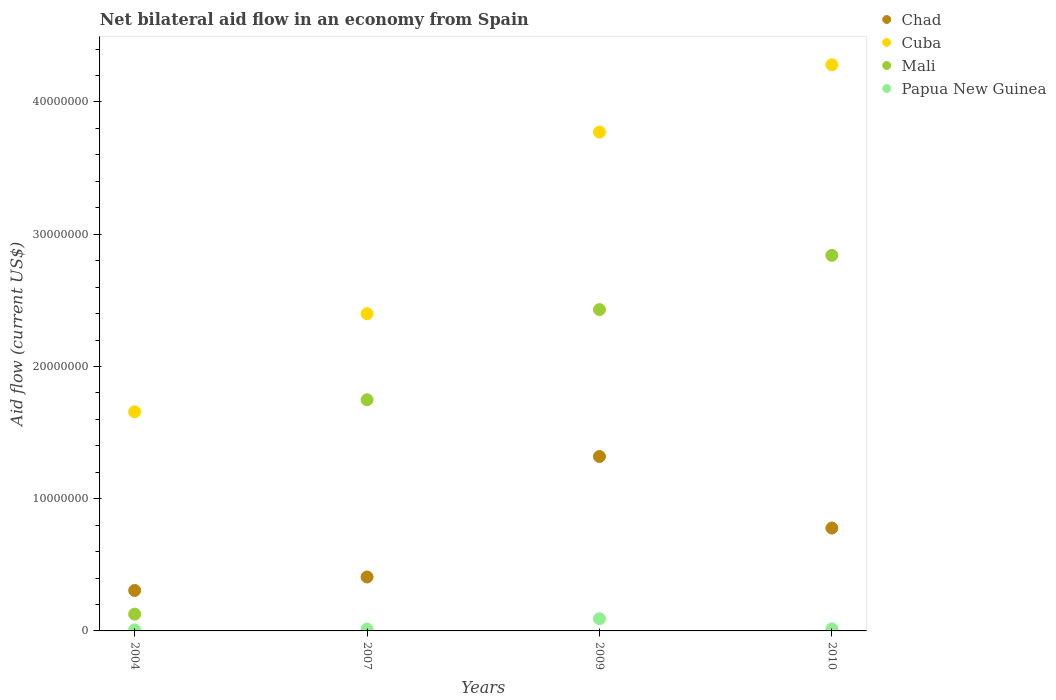Is the number of dotlines equal to the number of legend labels?
Your answer should be very brief. Yes. Across all years, what is the maximum net bilateral aid flow in Mali?
Ensure brevity in your answer.  2.84e+07. Across all years, what is the minimum net bilateral aid flow in Papua New Guinea?
Give a very brief answer. 8.00e+04. In which year was the net bilateral aid flow in Chad maximum?
Offer a very short reply. 2009. What is the total net bilateral aid flow in Mali in the graph?
Offer a very short reply. 7.14e+07. What is the difference between the net bilateral aid flow in Chad in 2007 and that in 2010?
Give a very brief answer. -3.70e+06. What is the difference between the net bilateral aid flow in Cuba in 2007 and the net bilateral aid flow in Chad in 2009?
Give a very brief answer. 1.08e+07. What is the average net bilateral aid flow in Chad per year?
Provide a short and direct response. 7.03e+06. In the year 2010, what is the difference between the net bilateral aid flow in Chad and net bilateral aid flow in Mali?
Give a very brief answer. -2.06e+07. In how many years, is the net bilateral aid flow in Papua New Guinea greater than 30000000 US$?
Your response must be concise. 0. What is the ratio of the net bilateral aid flow in Chad in 2007 to that in 2009?
Your response must be concise. 0.31. Is the net bilateral aid flow in Mali in 2004 less than that in 2009?
Your answer should be compact. Yes. Is the difference between the net bilateral aid flow in Chad in 2004 and 2009 greater than the difference between the net bilateral aid flow in Mali in 2004 and 2009?
Offer a terse response. Yes. What is the difference between the highest and the second highest net bilateral aid flow in Mali?
Your answer should be compact. 4.10e+06. What is the difference between the highest and the lowest net bilateral aid flow in Cuba?
Keep it short and to the point. 2.62e+07. In how many years, is the net bilateral aid flow in Mali greater than the average net bilateral aid flow in Mali taken over all years?
Offer a terse response. 2. Is the sum of the net bilateral aid flow in Papua New Guinea in 2004 and 2009 greater than the maximum net bilateral aid flow in Mali across all years?
Make the answer very short. No. Is it the case that in every year, the sum of the net bilateral aid flow in Mali and net bilateral aid flow in Chad  is greater than the net bilateral aid flow in Papua New Guinea?
Ensure brevity in your answer.  Yes. Does the net bilateral aid flow in Mali monotonically increase over the years?
Provide a succinct answer. Yes. Is the net bilateral aid flow in Mali strictly less than the net bilateral aid flow in Chad over the years?
Provide a short and direct response. No. How many dotlines are there?
Give a very brief answer. 4. How many years are there in the graph?
Offer a very short reply. 4. What is the difference between two consecutive major ticks on the Y-axis?
Give a very brief answer. 1.00e+07. Are the values on the major ticks of Y-axis written in scientific E-notation?
Your response must be concise. No. How many legend labels are there?
Your answer should be very brief. 4. How are the legend labels stacked?
Your response must be concise. Vertical. What is the title of the graph?
Make the answer very short. Net bilateral aid flow in an economy from Spain. Does "Liechtenstein" appear as one of the legend labels in the graph?
Offer a very short reply. No. What is the label or title of the X-axis?
Offer a terse response. Years. What is the Aid flow (current US$) in Chad in 2004?
Your response must be concise. 3.06e+06. What is the Aid flow (current US$) of Cuba in 2004?
Provide a succinct answer. 1.66e+07. What is the Aid flow (current US$) in Mali in 2004?
Keep it short and to the point. 1.27e+06. What is the Aid flow (current US$) in Papua New Guinea in 2004?
Offer a very short reply. 8.00e+04. What is the Aid flow (current US$) of Chad in 2007?
Your response must be concise. 4.08e+06. What is the Aid flow (current US$) in Cuba in 2007?
Offer a very short reply. 2.40e+07. What is the Aid flow (current US$) of Mali in 2007?
Provide a succinct answer. 1.75e+07. What is the Aid flow (current US$) in Chad in 2009?
Provide a short and direct response. 1.32e+07. What is the Aid flow (current US$) in Cuba in 2009?
Provide a succinct answer. 3.77e+07. What is the Aid flow (current US$) of Mali in 2009?
Your answer should be very brief. 2.43e+07. What is the Aid flow (current US$) in Papua New Guinea in 2009?
Ensure brevity in your answer.  9.20e+05. What is the Aid flow (current US$) in Chad in 2010?
Provide a succinct answer. 7.78e+06. What is the Aid flow (current US$) in Cuba in 2010?
Offer a terse response. 4.28e+07. What is the Aid flow (current US$) of Mali in 2010?
Offer a terse response. 2.84e+07. Across all years, what is the maximum Aid flow (current US$) in Chad?
Your answer should be very brief. 1.32e+07. Across all years, what is the maximum Aid flow (current US$) in Cuba?
Keep it short and to the point. 4.28e+07. Across all years, what is the maximum Aid flow (current US$) of Mali?
Keep it short and to the point. 2.84e+07. Across all years, what is the maximum Aid flow (current US$) in Papua New Guinea?
Provide a succinct answer. 9.20e+05. Across all years, what is the minimum Aid flow (current US$) in Chad?
Keep it short and to the point. 3.06e+06. Across all years, what is the minimum Aid flow (current US$) in Cuba?
Your response must be concise. 1.66e+07. Across all years, what is the minimum Aid flow (current US$) of Mali?
Your answer should be very brief. 1.27e+06. What is the total Aid flow (current US$) of Chad in the graph?
Your answer should be very brief. 2.81e+07. What is the total Aid flow (current US$) of Cuba in the graph?
Your answer should be compact. 1.21e+08. What is the total Aid flow (current US$) in Mali in the graph?
Your answer should be compact. 7.14e+07. What is the total Aid flow (current US$) in Papua New Guinea in the graph?
Your response must be concise. 1.29e+06. What is the difference between the Aid flow (current US$) of Chad in 2004 and that in 2007?
Offer a terse response. -1.02e+06. What is the difference between the Aid flow (current US$) in Cuba in 2004 and that in 2007?
Provide a succinct answer. -7.42e+06. What is the difference between the Aid flow (current US$) of Mali in 2004 and that in 2007?
Your response must be concise. -1.62e+07. What is the difference between the Aid flow (current US$) in Chad in 2004 and that in 2009?
Offer a terse response. -1.01e+07. What is the difference between the Aid flow (current US$) of Cuba in 2004 and that in 2009?
Ensure brevity in your answer.  -2.12e+07. What is the difference between the Aid flow (current US$) in Mali in 2004 and that in 2009?
Your response must be concise. -2.30e+07. What is the difference between the Aid flow (current US$) in Papua New Guinea in 2004 and that in 2009?
Your answer should be compact. -8.40e+05. What is the difference between the Aid flow (current US$) of Chad in 2004 and that in 2010?
Ensure brevity in your answer.  -4.72e+06. What is the difference between the Aid flow (current US$) in Cuba in 2004 and that in 2010?
Offer a very short reply. -2.62e+07. What is the difference between the Aid flow (current US$) of Mali in 2004 and that in 2010?
Provide a short and direct response. -2.71e+07. What is the difference between the Aid flow (current US$) in Chad in 2007 and that in 2009?
Your answer should be compact. -9.11e+06. What is the difference between the Aid flow (current US$) of Cuba in 2007 and that in 2009?
Your response must be concise. -1.37e+07. What is the difference between the Aid flow (current US$) in Mali in 2007 and that in 2009?
Your response must be concise. -6.82e+06. What is the difference between the Aid flow (current US$) of Papua New Guinea in 2007 and that in 2009?
Provide a short and direct response. -7.80e+05. What is the difference between the Aid flow (current US$) of Chad in 2007 and that in 2010?
Ensure brevity in your answer.  -3.70e+06. What is the difference between the Aid flow (current US$) of Cuba in 2007 and that in 2010?
Provide a succinct answer. -1.88e+07. What is the difference between the Aid flow (current US$) of Mali in 2007 and that in 2010?
Your answer should be compact. -1.09e+07. What is the difference between the Aid flow (current US$) of Papua New Guinea in 2007 and that in 2010?
Make the answer very short. -10000. What is the difference between the Aid flow (current US$) in Chad in 2009 and that in 2010?
Make the answer very short. 5.41e+06. What is the difference between the Aid flow (current US$) in Cuba in 2009 and that in 2010?
Your response must be concise. -5.09e+06. What is the difference between the Aid flow (current US$) of Mali in 2009 and that in 2010?
Offer a very short reply. -4.10e+06. What is the difference between the Aid flow (current US$) in Papua New Guinea in 2009 and that in 2010?
Your answer should be very brief. 7.70e+05. What is the difference between the Aid flow (current US$) of Chad in 2004 and the Aid flow (current US$) of Cuba in 2007?
Make the answer very short. -2.09e+07. What is the difference between the Aid flow (current US$) of Chad in 2004 and the Aid flow (current US$) of Mali in 2007?
Your answer should be very brief. -1.44e+07. What is the difference between the Aid flow (current US$) of Chad in 2004 and the Aid flow (current US$) of Papua New Guinea in 2007?
Ensure brevity in your answer.  2.92e+06. What is the difference between the Aid flow (current US$) in Cuba in 2004 and the Aid flow (current US$) in Mali in 2007?
Your response must be concise. -9.10e+05. What is the difference between the Aid flow (current US$) in Cuba in 2004 and the Aid flow (current US$) in Papua New Guinea in 2007?
Provide a short and direct response. 1.64e+07. What is the difference between the Aid flow (current US$) in Mali in 2004 and the Aid flow (current US$) in Papua New Guinea in 2007?
Provide a short and direct response. 1.13e+06. What is the difference between the Aid flow (current US$) in Chad in 2004 and the Aid flow (current US$) in Cuba in 2009?
Keep it short and to the point. -3.47e+07. What is the difference between the Aid flow (current US$) of Chad in 2004 and the Aid flow (current US$) of Mali in 2009?
Offer a very short reply. -2.12e+07. What is the difference between the Aid flow (current US$) in Chad in 2004 and the Aid flow (current US$) in Papua New Guinea in 2009?
Offer a very short reply. 2.14e+06. What is the difference between the Aid flow (current US$) of Cuba in 2004 and the Aid flow (current US$) of Mali in 2009?
Provide a succinct answer. -7.73e+06. What is the difference between the Aid flow (current US$) of Cuba in 2004 and the Aid flow (current US$) of Papua New Guinea in 2009?
Your response must be concise. 1.56e+07. What is the difference between the Aid flow (current US$) in Chad in 2004 and the Aid flow (current US$) in Cuba in 2010?
Make the answer very short. -3.98e+07. What is the difference between the Aid flow (current US$) of Chad in 2004 and the Aid flow (current US$) of Mali in 2010?
Offer a terse response. -2.53e+07. What is the difference between the Aid flow (current US$) of Chad in 2004 and the Aid flow (current US$) of Papua New Guinea in 2010?
Provide a succinct answer. 2.91e+06. What is the difference between the Aid flow (current US$) in Cuba in 2004 and the Aid flow (current US$) in Mali in 2010?
Keep it short and to the point. -1.18e+07. What is the difference between the Aid flow (current US$) of Cuba in 2004 and the Aid flow (current US$) of Papua New Guinea in 2010?
Offer a terse response. 1.64e+07. What is the difference between the Aid flow (current US$) of Mali in 2004 and the Aid flow (current US$) of Papua New Guinea in 2010?
Provide a succinct answer. 1.12e+06. What is the difference between the Aid flow (current US$) of Chad in 2007 and the Aid flow (current US$) of Cuba in 2009?
Your answer should be compact. -3.36e+07. What is the difference between the Aid flow (current US$) of Chad in 2007 and the Aid flow (current US$) of Mali in 2009?
Provide a short and direct response. -2.02e+07. What is the difference between the Aid flow (current US$) in Chad in 2007 and the Aid flow (current US$) in Papua New Guinea in 2009?
Give a very brief answer. 3.16e+06. What is the difference between the Aid flow (current US$) in Cuba in 2007 and the Aid flow (current US$) in Mali in 2009?
Your answer should be very brief. -3.10e+05. What is the difference between the Aid flow (current US$) of Cuba in 2007 and the Aid flow (current US$) of Papua New Guinea in 2009?
Make the answer very short. 2.31e+07. What is the difference between the Aid flow (current US$) in Mali in 2007 and the Aid flow (current US$) in Papua New Guinea in 2009?
Ensure brevity in your answer.  1.66e+07. What is the difference between the Aid flow (current US$) in Chad in 2007 and the Aid flow (current US$) in Cuba in 2010?
Your response must be concise. -3.87e+07. What is the difference between the Aid flow (current US$) in Chad in 2007 and the Aid flow (current US$) in Mali in 2010?
Make the answer very short. -2.43e+07. What is the difference between the Aid flow (current US$) of Chad in 2007 and the Aid flow (current US$) of Papua New Guinea in 2010?
Your answer should be very brief. 3.93e+06. What is the difference between the Aid flow (current US$) in Cuba in 2007 and the Aid flow (current US$) in Mali in 2010?
Make the answer very short. -4.41e+06. What is the difference between the Aid flow (current US$) in Cuba in 2007 and the Aid flow (current US$) in Papua New Guinea in 2010?
Offer a terse response. 2.38e+07. What is the difference between the Aid flow (current US$) in Mali in 2007 and the Aid flow (current US$) in Papua New Guinea in 2010?
Your answer should be compact. 1.73e+07. What is the difference between the Aid flow (current US$) in Chad in 2009 and the Aid flow (current US$) in Cuba in 2010?
Your answer should be compact. -2.96e+07. What is the difference between the Aid flow (current US$) of Chad in 2009 and the Aid flow (current US$) of Mali in 2010?
Keep it short and to the point. -1.52e+07. What is the difference between the Aid flow (current US$) of Chad in 2009 and the Aid flow (current US$) of Papua New Guinea in 2010?
Ensure brevity in your answer.  1.30e+07. What is the difference between the Aid flow (current US$) of Cuba in 2009 and the Aid flow (current US$) of Mali in 2010?
Your response must be concise. 9.32e+06. What is the difference between the Aid flow (current US$) in Cuba in 2009 and the Aid flow (current US$) in Papua New Guinea in 2010?
Your answer should be compact. 3.76e+07. What is the difference between the Aid flow (current US$) of Mali in 2009 and the Aid flow (current US$) of Papua New Guinea in 2010?
Keep it short and to the point. 2.42e+07. What is the average Aid flow (current US$) in Chad per year?
Provide a succinct answer. 7.03e+06. What is the average Aid flow (current US$) of Cuba per year?
Your response must be concise. 3.03e+07. What is the average Aid flow (current US$) of Mali per year?
Your response must be concise. 1.79e+07. What is the average Aid flow (current US$) of Papua New Guinea per year?
Ensure brevity in your answer.  3.22e+05. In the year 2004, what is the difference between the Aid flow (current US$) in Chad and Aid flow (current US$) in Cuba?
Ensure brevity in your answer.  -1.35e+07. In the year 2004, what is the difference between the Aid flow (current US$) in Chad and Aid flow (current US$) in Mali?
Your answer should be very brief. 1.79e+06. In the year 2004, what is the difference between the Aid flow (current US$) of Chad and Aid flow (current US$) of Papua New Guinea?
Offer a very short reply. 2.98e+06. In the year 2004, what is the difference between the Aid flow (current US$) in Cuba and Aid flow (current US$) in Mali?
Your answer should be compact. 1.53e+07. In the year 2004, what is the difference between the Aid flow (current US$) of Cuba and Aid flow (current US$) of Papua New Guinea?
Your answer should be compact. 1.65e+07. In the year 2004, what is the difference between the Aid flow (current US$) of Mali and Aid flow (current US$) of Papua New Guinea?
Your answer should be very brief. 1.19e+06. In the year 2007, what is the difference between the Aid flow (current US$) in Chad and Aid flow (current US$) in Cuba?
Your answer should be very brief. -1.99e+07. In the year 2007, what is the difference between the Aid flow (current US$) of Chad and Aid flow (current US$) of Mali?
Provide a succinct answer. -1.34e+07. In the year 2007, what is the difference between the Aid flow (current US$) of Chad and Aid flow (current US$) of Papua New Guinea?
Make the answer very short. 3.94e+06. In the year 2007, what is the difference between the Aid flow (current US$) in Cuba and Aid flow (current US$) in Mali?
Provide a short and direct response. 6.51e+06. In the year 2007, what is the difference between the Aid flow (current US$) of Cuba and Aid flow (current US$) of Papua New Guinea?
Offer a very short reply. 2.38e+07. In the year 2007, what is the difference between the Aid flow (current US$) in Mali and Aid flow (current US$) in Papua New Guinea?
Keep it short and to the point. 1.73e+07. In the year 2009, what is the difference between the Aid flow (current US$) of Chad and Aid flow (current US$) of Cuba?
Your answer should be very brief. -2.45e+07. In the year 2009, what is the difference between the Aid flow (current US$) in Chad and Aid flow (current US$) in Mali?
Provide a succinct answer. -1.11e+07. In the year 2009, what is the difference between the Aid flow (current US$) in Chad and Aid flow (current US$) in Papua New Guinea?
Your answer should be very brief. 1.23e+07. In the year 2009, what is the difference between the Aid flow (current US$) in Cuba and Aid flow (current US$) in Mali?
Your answer should be compact. 1.34e+07. In the year 2009, what is the difference between the Aid flow (current US$) in Cuba and Aid flow (current US$) in Papua New Guinea?
Offer a terse response. 3.68e+07. In the year 2009, what is the difference between the Aid flow (current US$) of Mali and Aid flow (current US$) of Papua New Guinea?
Your answer should be compact. 2.34e+07. In the year 2010, what is the difference between the Aid flow (current US$) in Chad and Aid flow (current US$) in Cuba?
Offer a very short reply. -3.50e+07. In the year 2010, what is the difference between the Aid flow (current US$) in Chad and Aid flow (current US$) in Mali?
Keep it short and to the point. -2.06e+07. In the year 2010, what is the difference between the Aid flow (current US$) in Chad and Aid flow (current US$) in Papua New Guinea?
Ensure brevity in your answer.  7.63e+06. In the year 2010, what is the difference between the Aid flow (current US$) of Cuba and Aid flow (current US$) of Mali?
Provide a succinct answer. 1.44e+07. In the year 2010, what is the difference between the Aid flow (current US$) of Cuba and Aid flow (current US$) of Papua New Guinea?
Give a very brief answer. 4.27e+07. In the year 2010, what is the difference between the Aid flow (current US$) of Mali and Aid flow (current US$) of Papua New Guinea?
Give a very brief answer. 2.82e+07. What is the ratio of the Aid flow (current US$) in Chad in 2004 to that in 2007?
Give a very brief answer. 0.75. What is the ratio of the Aid flow (current US$) in Cuba in 2004 to that in 2007?
Provide a succinct answer. 0.69. What is the ratio of the Aid flow (current US$) in Mali in 2004 to that in 2007?
Offer a very short reply. 0.07. What is the ratio of the Aid flow (current US$) of Papua New Guinea in 2004 to that in 2007?
Your answer should be very brief. 0.57. What is the ratio of the Aid flow (current US$) in Chad in 2004 to that in 2009?
Ensure brevity in your answer.  0.23. What is the ratio of the Aid flow (current US$) of Cuba in 2004 to that in 2009?
Keep it short and to the point. 0.44. What is the ratio of the Aid flow (current US$) in Mali in 2004 to that in 2009?
Offer a very short reply. 0.05. What is the ratio of the Aid flow (current US$) of Papua New Guinea in 2004 to that in 2009?
Your response must be concise. 0.09. What is the ratio of the Aid flow (current US$) in Chad in 2004 to that in 2010?
Your answer should be compact. 0.39. What is the ratio of the Aid flow (current US$) of Cuba in 2004 to that in 2010?
Provide a short and direct response. 0.39. What is the ratio of the Aid flow (current US$) of Mali in 2004 to that in 2010?
Provide a short and direct response. 0.04. What is the ratio of the Aid flow (current US$) of Papua New Guinea in 2004 to that in 2010?
Offer a very short reply. 0.53. What is the ratio of the Aid flow (current US$) of Chad in 2007 to that in 2009?
Offer a very short reply. 0.31. What is the ratio of the Aid flow (current US$) in Cuba in 2007 to that in 2009?
Offer a terse response. 0.64. What is the ratio of the Aid flow (current US$) in Mali in 2007 to that in 2009?
Offer a very short reply. 0.72. What is the ratio of the Aid flow (current US$) in Papua New Guinea in 2007 to that in 2009?
Provide a short and direct response. 0.15. What is the ratio of the Aid flow (current US$) in Chad in 2007 to that in 2010?
Offer a very short reply. 0.52. What is the ratio of the Aid flow (current US$) of Cuba in 2007 to that in 2010?
Offer a terse response. 0.56. What is the ratio of the Aid flow (current US$) in Mali in 2007 to that in 2010?
Make the answer very short. 0.62. What is the ratio of the Aid flow (current US$) in Papua New Guinea in 2007 to that in 2010?
Provide a succinct answer. 0.93. What is the ratio of the Aid flow (current US$) of Chad in 2009 to that in 2010?
Keep it short and to the point. 1.7. What is the ratio of the Aid flow (current US$) of Cuba in 2009 to that in 2010?
Give a very brief answer. 0.88. What is the ratio of the Aid flow (current US$) in Mali in 2009 to that in 2010?
Make the answer very short. 0.86. What is the ratio of the Aid flow (current US$) of Papua New Guinea in 2009 to that in 2010?
Give a very brief answer. 6.13. What is the difference between the highest and the second highest Aid flow (current US$) of Chad?
Make the answer very short. 5.41e+06. What is the difference between the highest and the second highest Aid flow (current US$) of Cuba?
Provide a succinct answer. 5.09e+06. What is the difference between the highest and the second highest Aid flow (current US$) in Mali?
Your response must be concise. 4.10e+06. What is the difference between the highest and the second highest Aid flow (current US$) in Papua New Guinea?
Keep it short and to the point. 7.70e+05. What is the difference between the highest and the lowest Aid flow (current US$) of Chad?
Your answer should be very brief. 1.01e+07. What is the difference between the highest and the lowest Aid flow (current US$) of Cuba?
Provide a short and direct response. 2.62e+07. What is the difference between the highest and the lowest Aid flow (current US$) in Mali?
Your answer should be very brief. 2.71e+07. What is the difference between the highest and the lowest Aid flow (current US$) of Papua New Guinea?
Provide a succinct answer. 8.40e+05. 